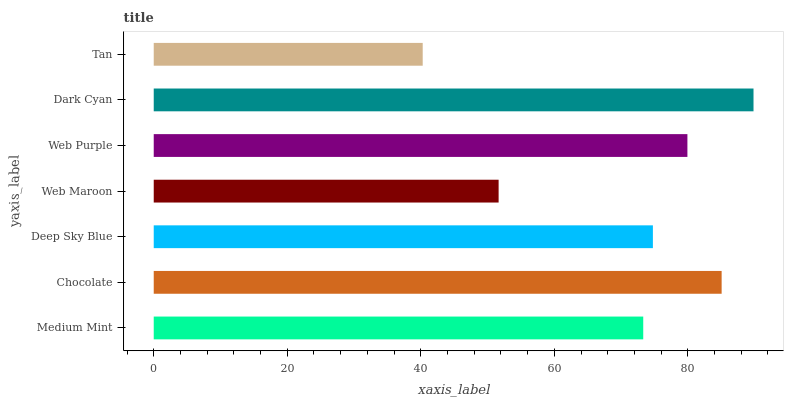Is Tan the minimum?
Answer yes or no. Yes. Is Dark Cyan the maximum?
Answer yes or no. Yes. Is Chocolate the minimum?
Answer yes or no. No. Is Chocolate the maximum?
Answer yes or no. No. Is Chocolate greater than Medium Mint?
Answer yes or no. Yes. Is Medium Mint less than Chocolate?
Answer yes or no. Yes. Is Medium Mint greater than Chocolate?
Answer yes or no. No. Is Chocolate less than Medium Mint?
Answer yes or no. No. Is Deep Sky Blue the high median?
Answer yes or no. Yes. Is Deep Sky Blue the low median?
Answer yes or no. Yes. Is Dark Cyan the high median?
Answer yes or no. No. Is Dark Cyan the low median?
Answer yes or no. No. 